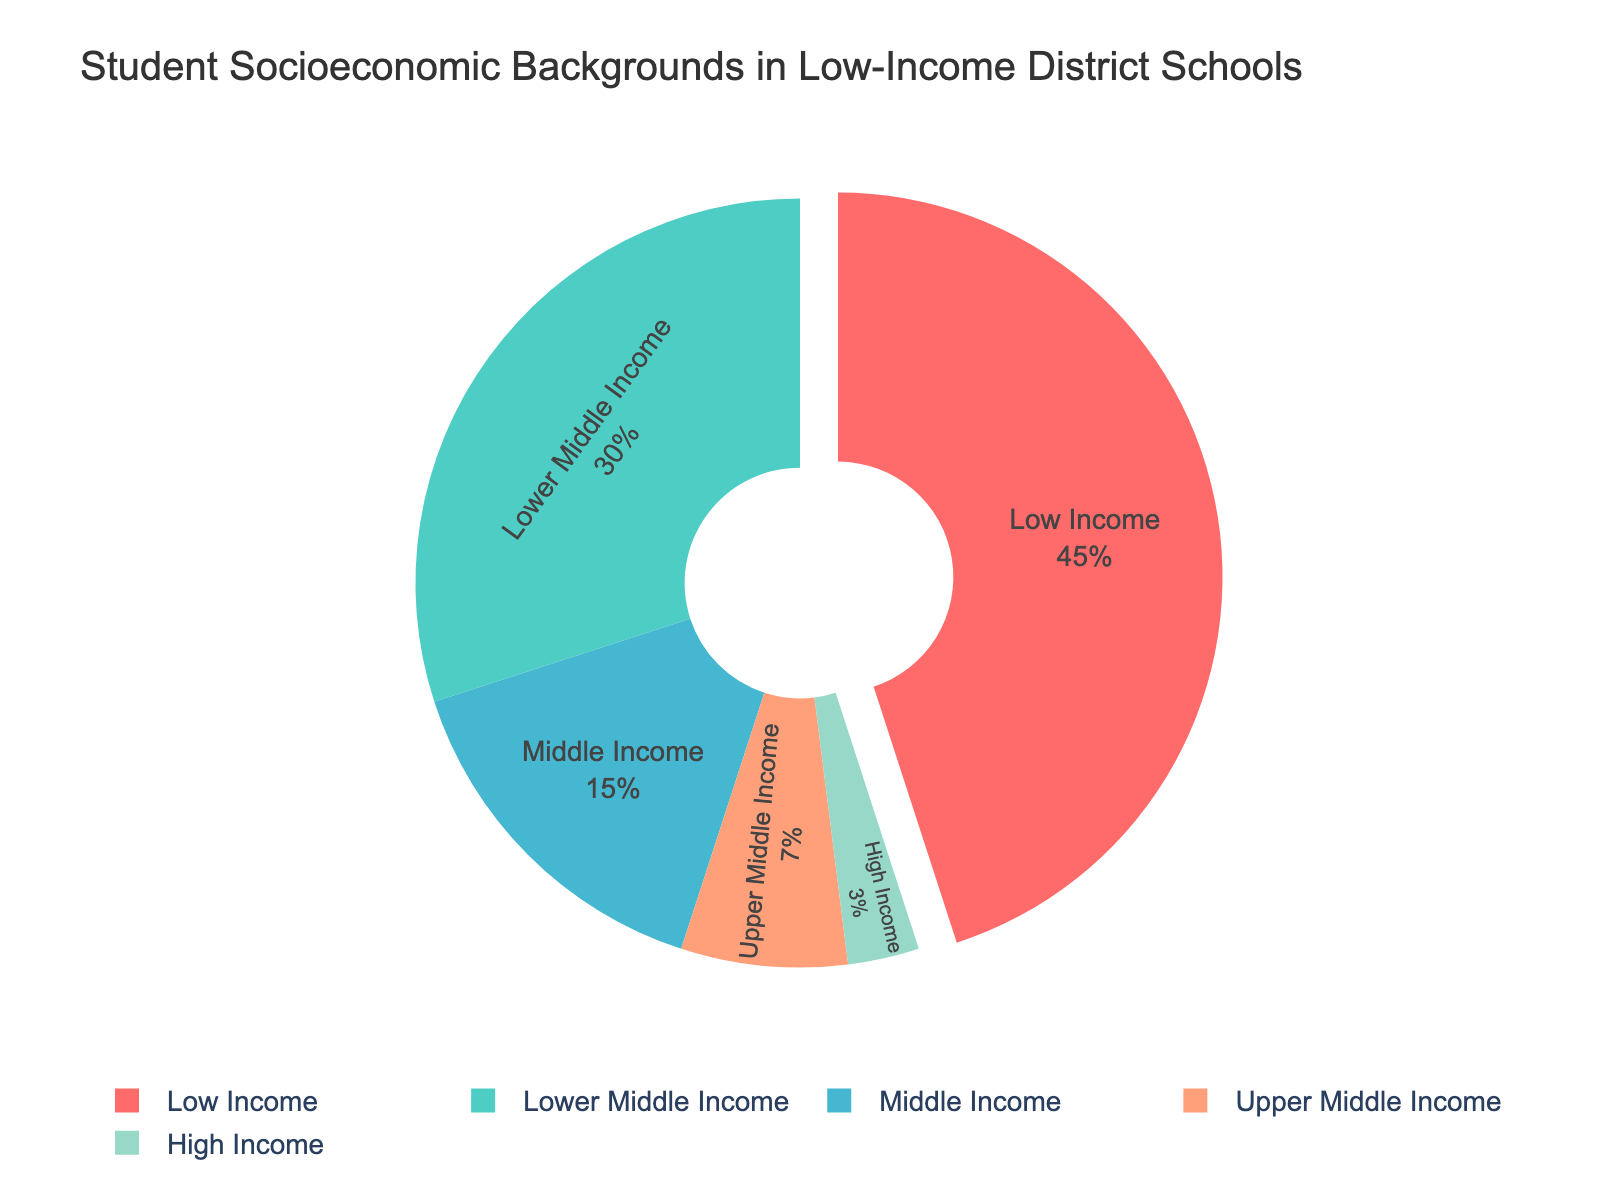What's the largest socioeconomic group represented in the pie chart? The largest group in the pie chart represents the "Low Income" background. This can be seen as it occupies the largest segment in the chart.
Answer: Low Income What's the sum of percentages of students from "Lower Middle Income" and "Middle Income" backgrounds? The percentages for "Lower Middle Income" and "Middle Income" are 30% and 15%, respectively. Adding these together gives 30% + 15% = 45%.
Answer: 45% How much larger is the "Low Income" group compared to the "High Income" group? The "Low Income" group is 45%, and the "High Income" group is 3%. The difference is 45% - 3% = 42%.
Answer: 42% What percentage of students come from "Middle Income" and "Upper Middle Income" backgrounds combined? The percentages for "Middle Income" and "Upper Middle Income" are 15% and 7%, respectively. Adding these together gives 15% + 7% = 22%.
Answer: 22% Which socioeconomic group occupies the smallest portion of the pie chart? The smallest segment in the pie chart represents students from the "High Income" background, occupying 3%.
Answer: High Income How does the percentage of students from "Upper Middle Income" backgrounds compare to those from "Middle Income" backgrounds? The percentage for "Upper Middle Income" is 7%, while for "Middle Income" it is 15%. Thus, "Middle Income" has a higher percentage than "Upper Middle Income".
Answer: Middle Income is higher How much larger is the total percentage of students in "Lower Middle Income" and "High Income" groups compared to "Upper Middle Income" group? The total percentage for "Lower Middle Income" and "High Income" is 30% + 3% = 33%. The percentage for "Upper Middle Income" is 7%. The difference is 33% - 7% = 26%.
Answer: 26% What is the difference between the sum of "Low Income" and "High Income" groups and the sum of "Lower Middle Income" and "Middle Income" groups? The sum of "Low Income" and "High Income" is 45% + 3% = 48%. The sum of "Lower Middle Income" and "Middle Income" is 30% + 15% = 45%. The difference is 48% - 45% = 3%.
Answer: 3% Which color represents the "Middle Income" group on the pie chart? In the pie chart, the "Middle Income" group is represented by the color blue.
Answer: Blue 